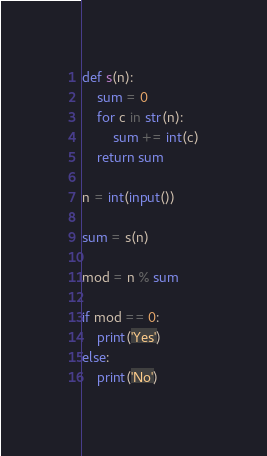<code> <loc_0><loc_0><loc_500><loc_500><_Python_>

def s(n):
	sum = 0
	for c in str(n):
		sum += int(c)
	return sum

n = int(input())

sum = s(n)

mod = n % sum

if mod == 0:
	print('Yes')
else:
	print('No')</code> 